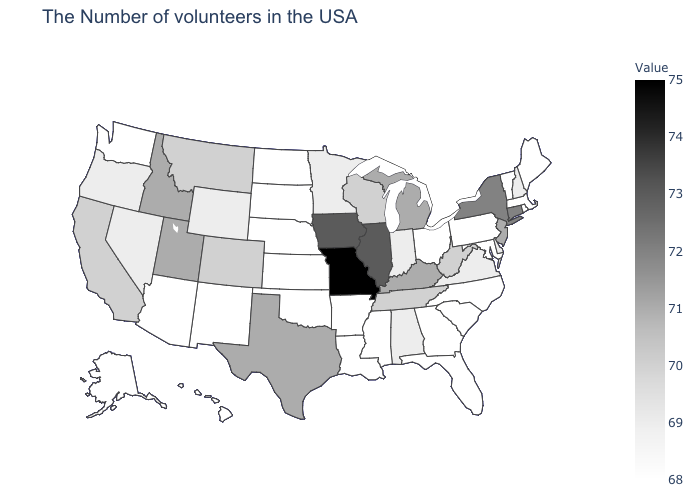Does Arizona have the lowest value in the USA?
Write a very short answer. Yes. Which states have the lowest value in the USA?
Be succinct. Maine, Massachusetts, Rhode Island, Vermont, Maryland, Pennsylvania, North Carolina, South Carolina, Ohio, Florida, Georgia, Mississippi, Louisiana, Arkansas, Kansas, Nebraska, Oklahoma, South Dakota, North Dakota, New Mexico, Arizona, Washington, Alaska, Hawaii. Which states have the highest value in the USA?
Answer briefly. Missouri. 